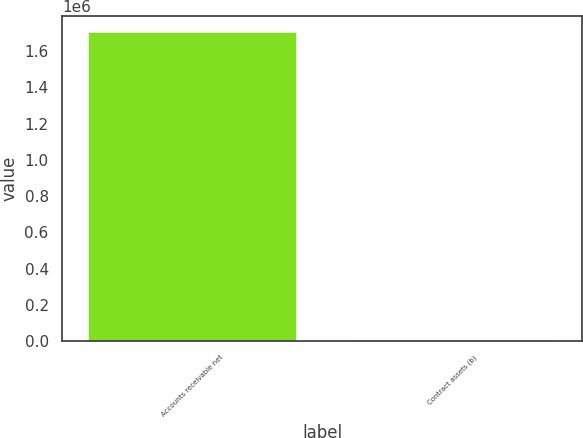Convert chart to OTSL. <chart><loc_0><loc_0><loc_500><loc_500><bar_chart><fcel>Accounts receivable net<fcel>Contract assets (b)<nl><fcel>1.7088e+06<fcel>4499<nl></chart> 